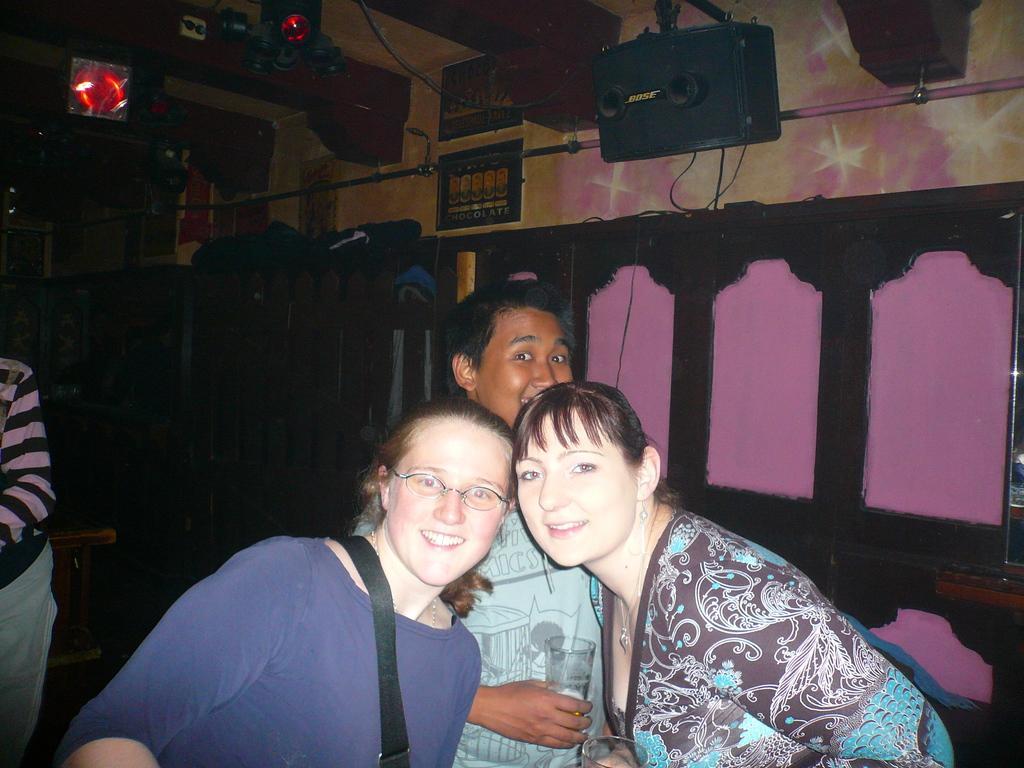Could you give a brief overview of what you see in this image? In this image I can see people among them these two women are smiling and this man is holding a glass. In the background I can see some objects attached to the wall. 